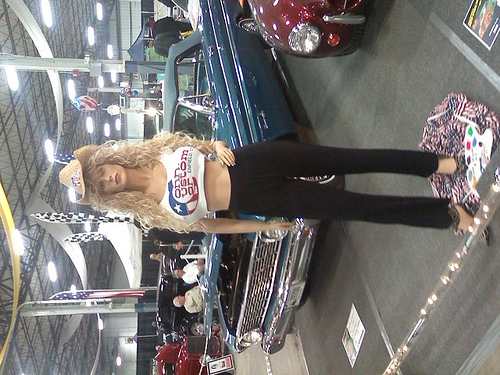<image>
Is there a mannequin behind the car? No. The mannequin is not behind the car. From this viewpoint, the mannequin appears to be positioned elsewhere in the scene. 